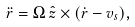Convert formula to latex. <formula><loc_0><loc_0><loc_500><loc_500>\ddot { r } = \Omega \, { \hat { z } } \times ( \dot { r } - { v } _ { s } ) ,</formula> 